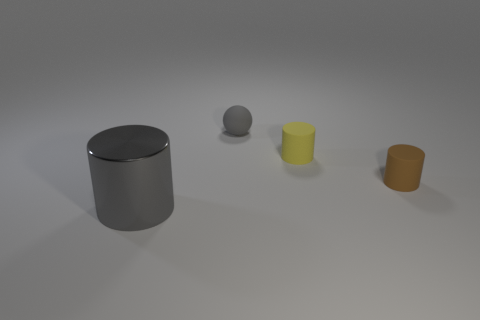Add 4 large blue matte cylinders. How many objects exist? 8 Subtract all cylinders. How many objects are left? 1 Subtract all gray cubes. Subtract all yellow rubber things. How many objects are left? 3 Add 3 large metallic things. How many large metallic things are left? 4 Add 1 brown cylinders. How many brown cylinders exist? 2 Subtract 1 gray cylinders. How many objects are left? 3 